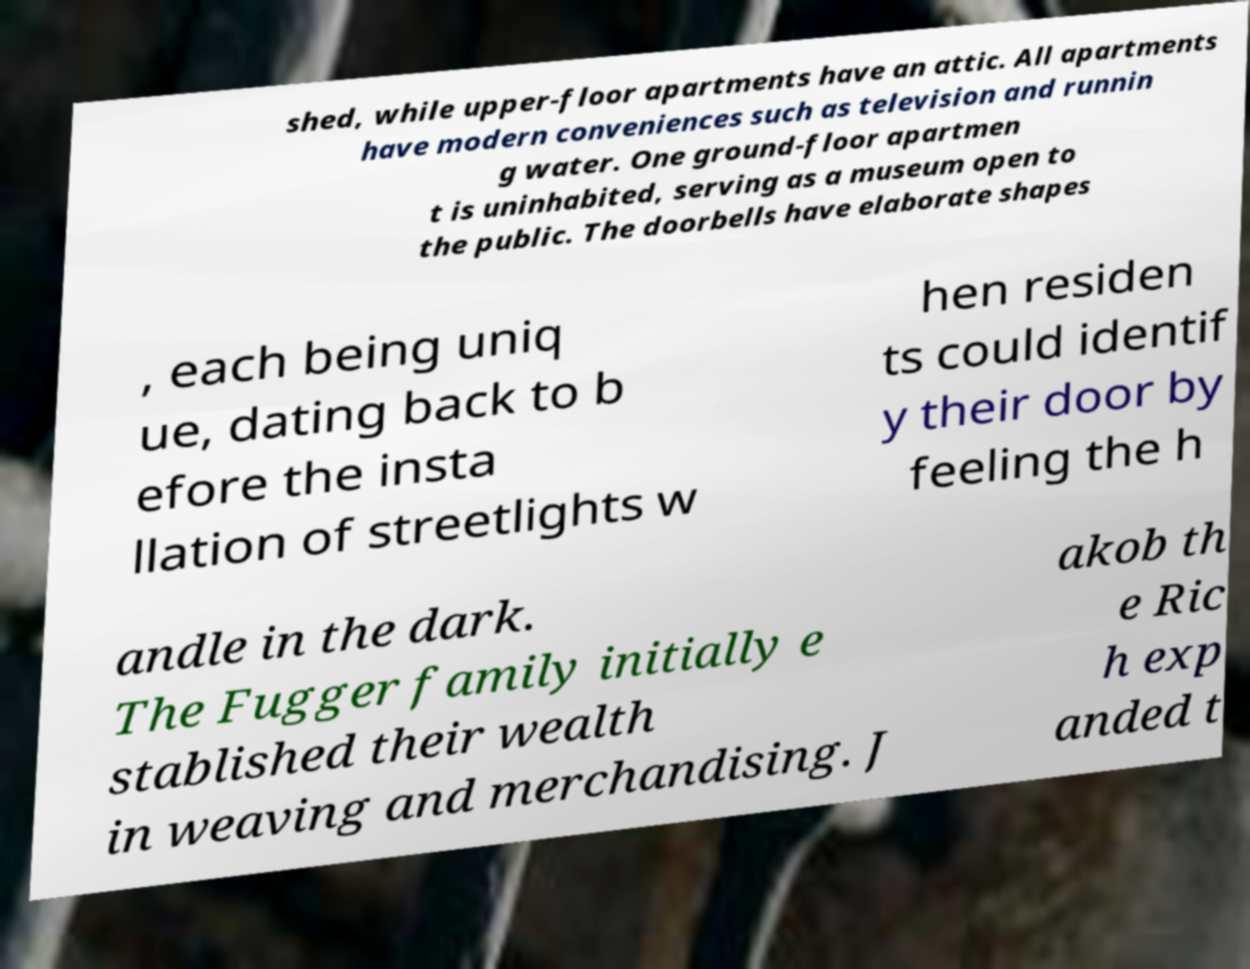I need the written content from this picture converted into text. Can you do that? shed, while upper-floor apartments have an attic. All apartments have modern conveniences such as television and runnin g water. One ground-floor apartmen t is uninhabited, serving as a museum open to the public. The doorbells have elaborate shapes , each being uniq ue, dating back to b efore the insta llation of streetlights w hen residen ts could identif y their door by feeling the h andle in the dark. The Fugger family initially e stablished their wealth in weaving and merchandising. J akob th e Ric h exp anded t 